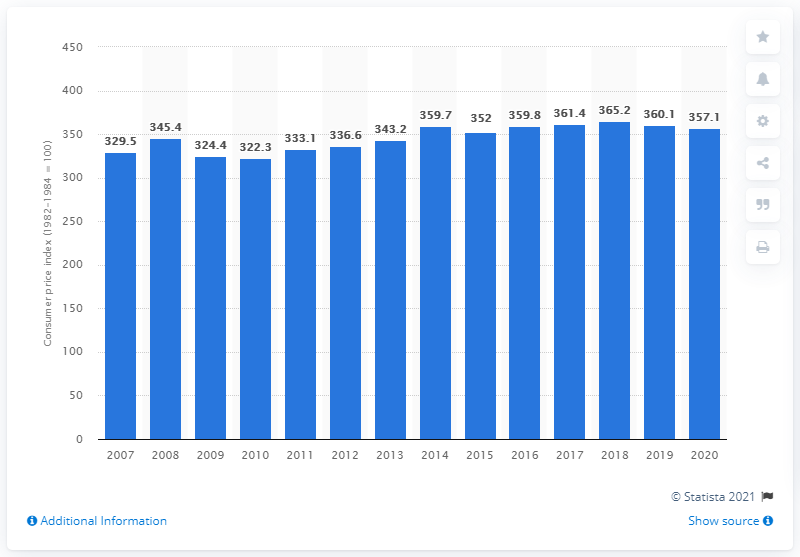Mention a couple of crucial points in this snapshot. In 2020, the average Consumer Price Index (CPI) for fresh fruit was 357.1. 